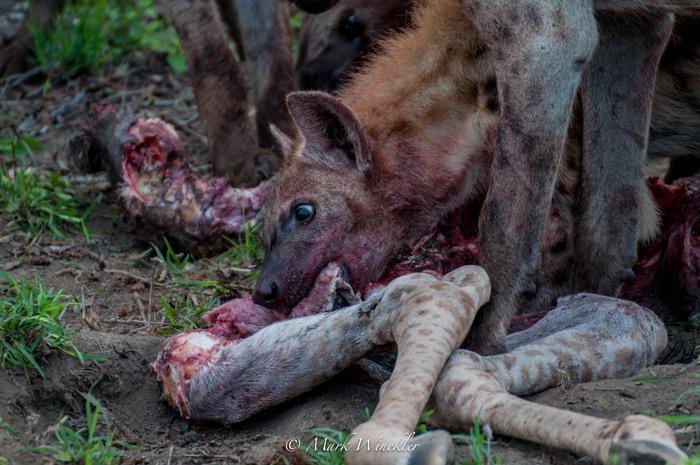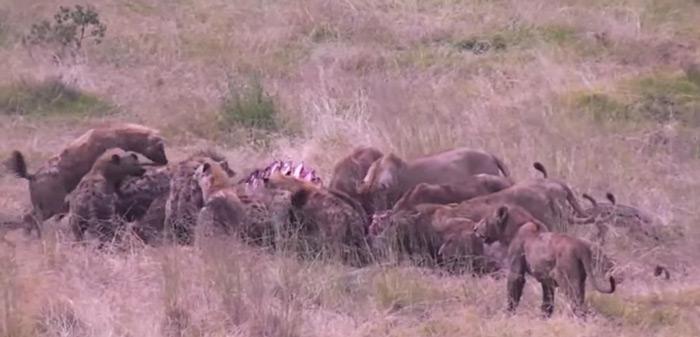The first image is the image on the left, the second image is the image on the right. For the images shown, is this caption "One of the images features only one hyena." true? Answer yes or no. Yes. The first image is the image on the left, the second image is the image on the right. For the images displayed, is the sentence "An image shows a hyena near the carcass of a giraffe with its spotted hooved legs visible." factually correct? Answer yes or no. Yes. 